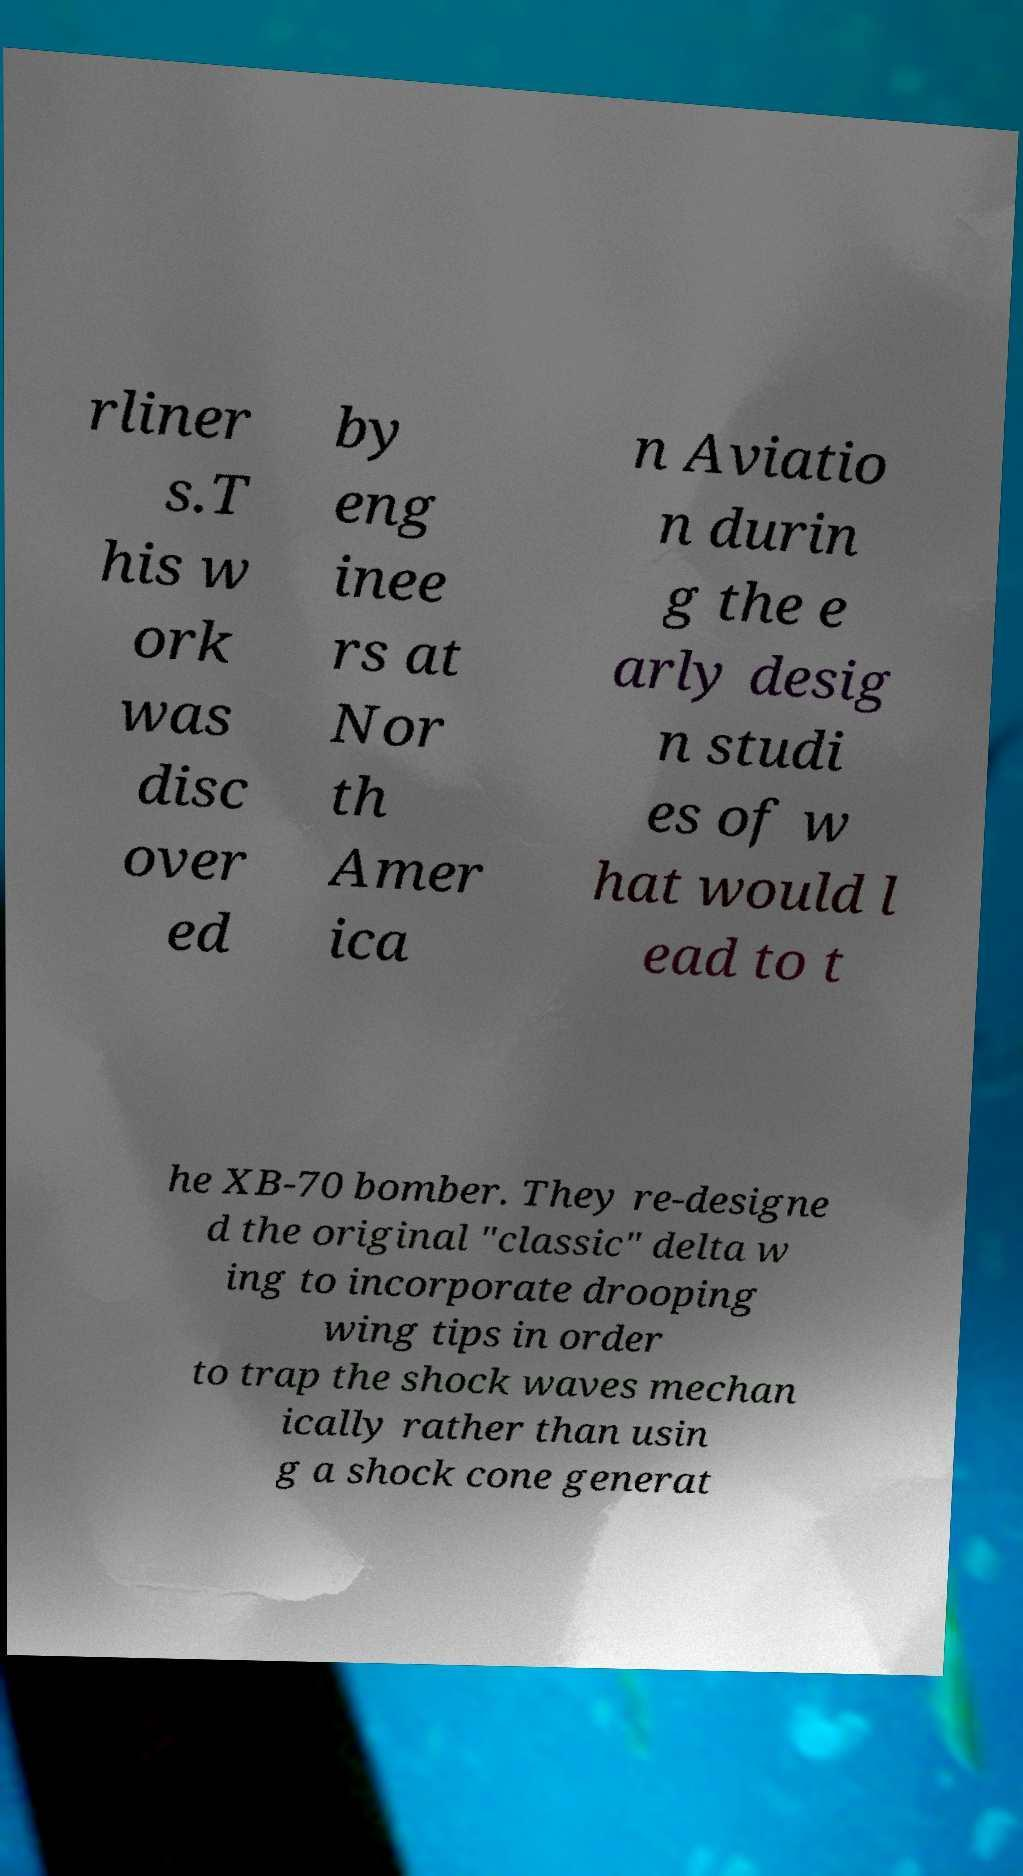There's text embedded in this image that I need extracted. Can you transcribe it verbatim? rliner s.T his w ork was disc over ed by eng inee rs at Nor th Amer ica n Aviatio n durin g the e arly desig n studi es of w hat would l ead to t he XB-70 bomber. They re-designe d the original "classic" delta w ing to incorporate drooping wing tips in order to trap the shock waves mechan ically rather than usin g a shock cone generat 